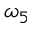<formula> <loc_0><loc_0><loc_500><loc_500>\omega _ { 5 }</formula> 